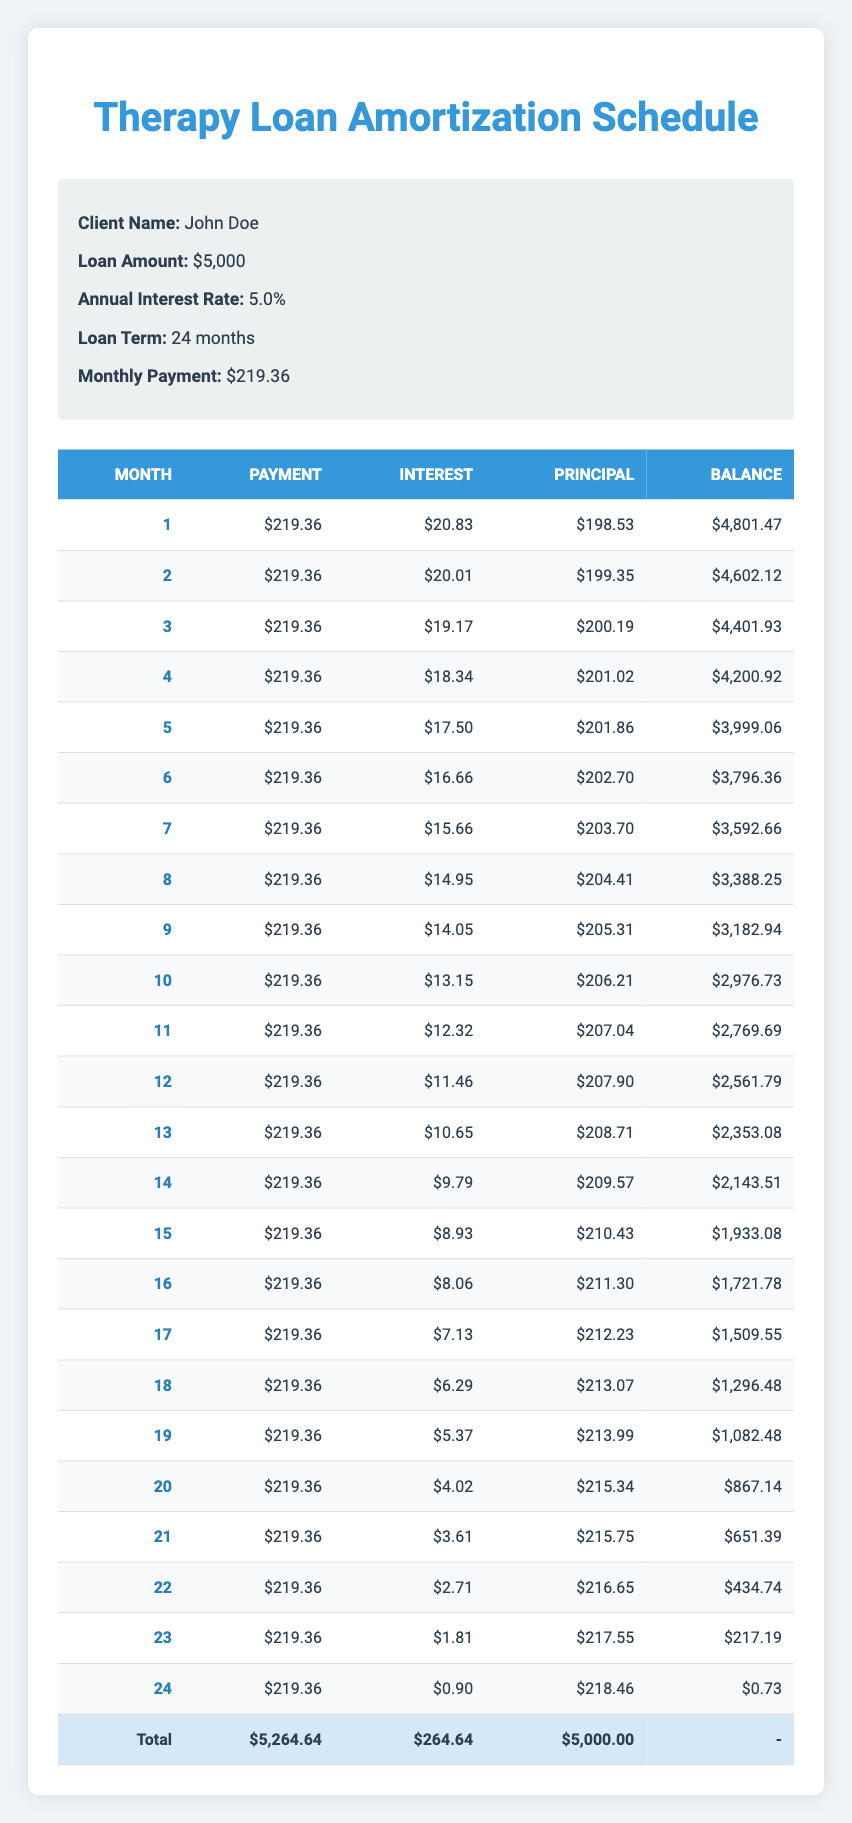What is the total amount paid over the course of the therapy loan? By looking at the last row of the table, the total payment amount is listed as $5,264.64
Answer: 5,264.64 How much is the principal payment in the 12th month? Referring to the 12th month's row in the amortization schedule, the principal payment is $207.90
Answer: 207.90 What is the interest payment in the first month? In the first month's row, the interest payment is clearly stated as $20.83
Answer: 20.83 Was the monthly payment consistent throughout the loan period? The monthly payment is listed as $219.36 for every month in the table, confirming it remained consistent
Answer: Yes How much did John pay in interest over the entire loan term? To find the total interest paid, we can refer to the total interest column which states $264.64 as the accumulated interest for the entire loan term
Answer: 264.64 What is the remaining balance after 6 months? In the 6th month, the remaining balance is listed as $3,796.36 which indicates how much is left to be paid after that period
Answer: 3,796.36 What was the change in the remaining balance from month 1 to month 2? The remaining balance decreased from $4,801.47 in month 1 to $4,602.12 in month 2. Calculating the change is $4,801.47 - $4,602.12 = $199.35
Answer: 199.35 What is the average monthly principal payment over the loan term? To calculate the average monthly principal payment, we take the total principal paid ($5,000.00 from the total row) and divide by the number of payments (24). This gives us an average principal payment of $5,000.00 / 24 = $208.33
Answer: 208.33 In month 20, was the interest payment lower than $5? The interest payment for month 20 is given as $4.02, which is indeed lower than $5, confirming the statement
Answer: Yes 